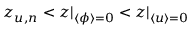Convert formula to latex. <formula><loc_0><loc_0><loc_500><loc_500>z _ { u , n } < z | _ { \langle \phi \rangle = 0 } < z | _ { \langle u \rangle = 0 }</formula> 